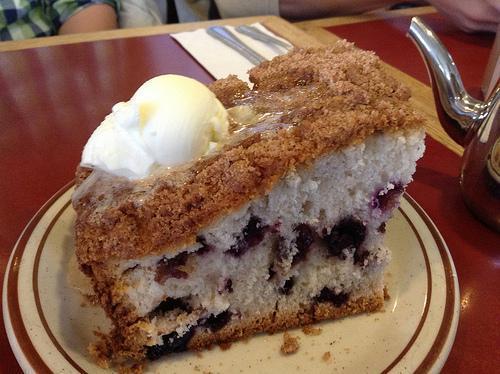How many servings?
Give a very brief answer. 1. 